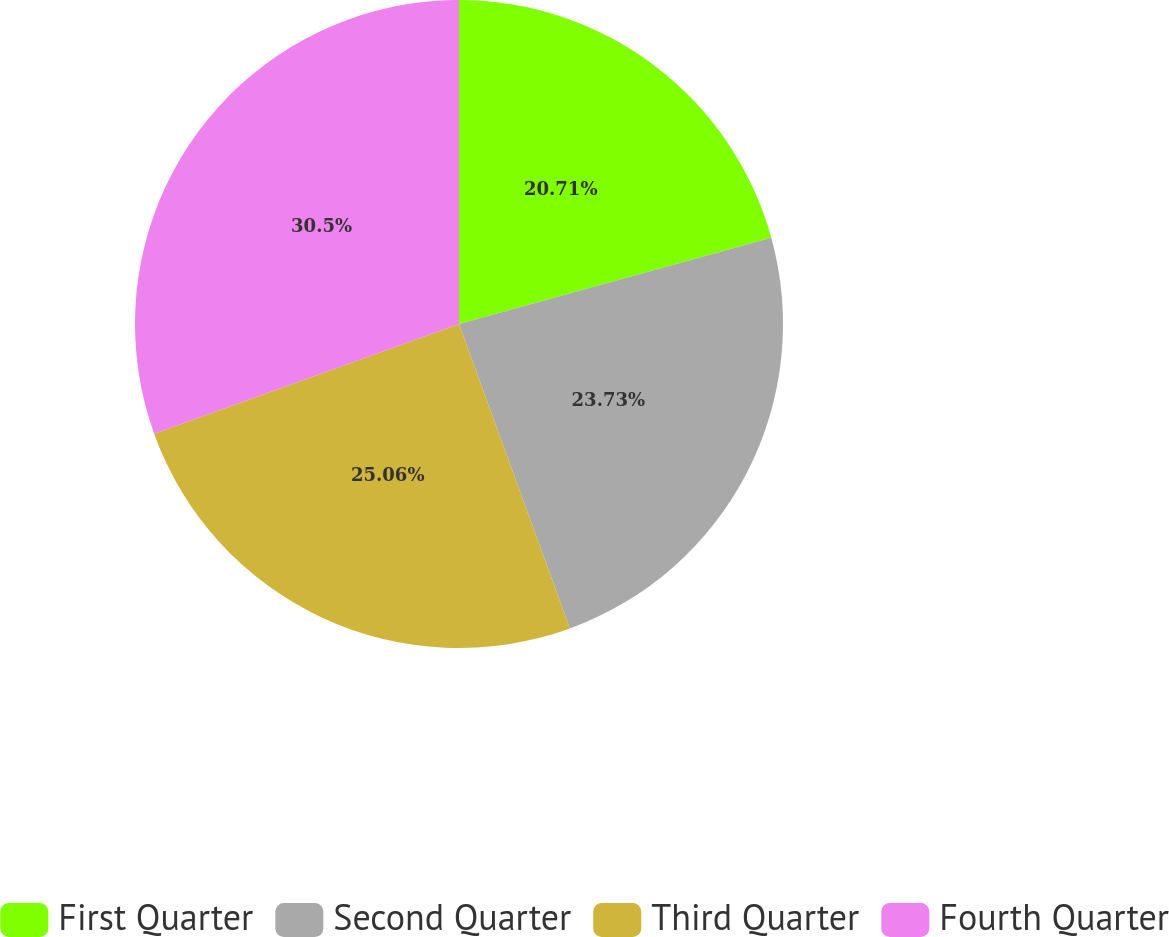Convert chart. <chart><loc_0><loc_0><loc_500><loc_500><pie_chart><fcel>First Quarter<fcel>Second Quarter<fcel>Third Quarter<fcel>Fourth Quarter<nl><fcel>20.71%<fcel>23.73%<fcel>25.06%<fcel>30.5%<nl></chart> 